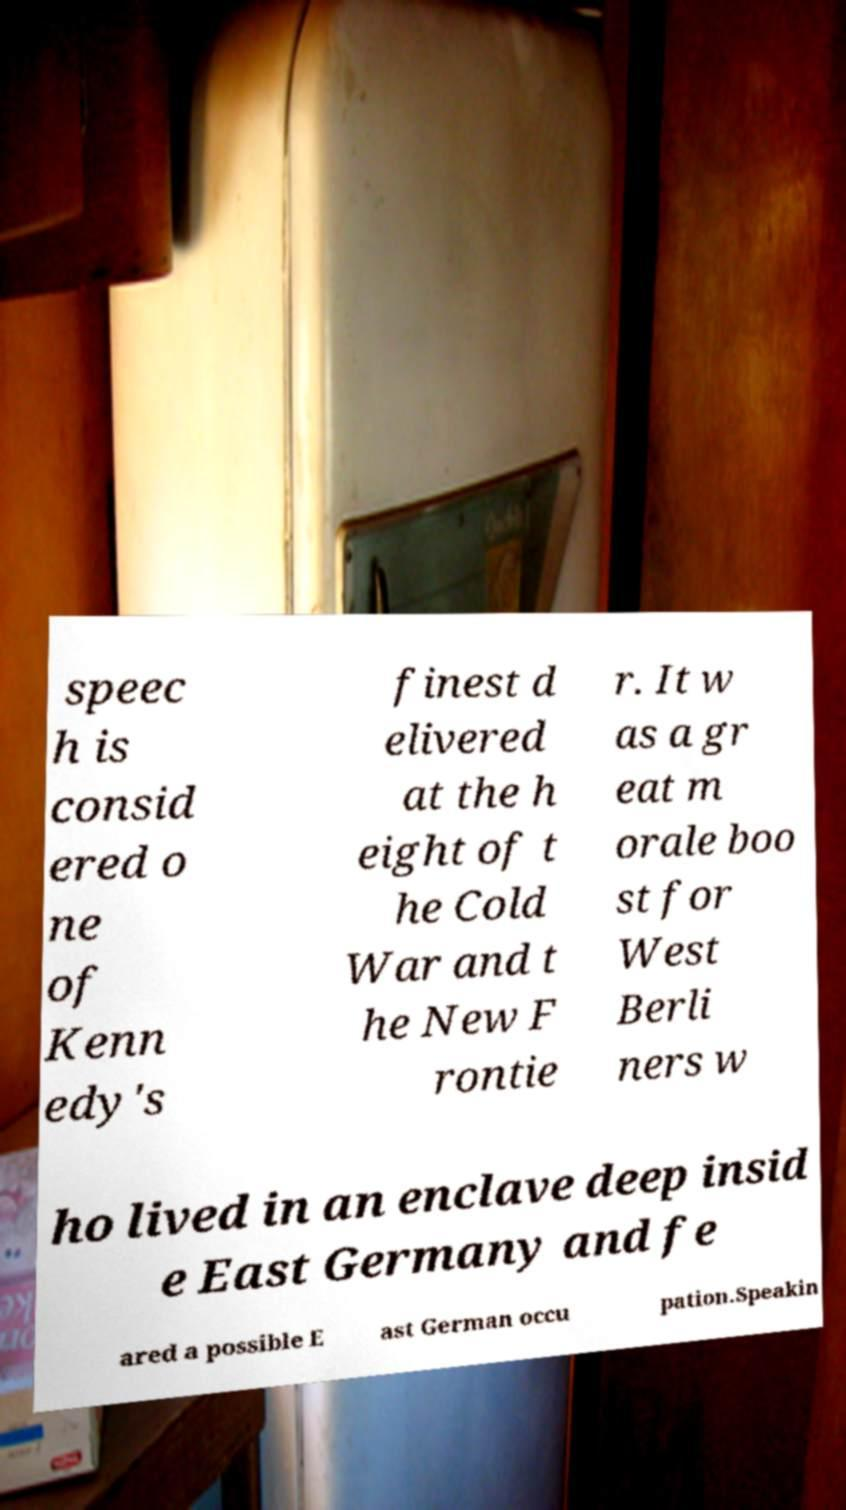There's text embedded in this image that I need extracted. Can you transcribe it verbatim? speec h is consid ered o ne of Kenn edy's finest d elivered at the h eight of t he Cold War and t he New F rontie r. It w as a gr eat m orale boo st for West Berli ners w ho lived in an enclave deep insid e East Germany and fe ared a possible E ast German occu pation.Speakin 